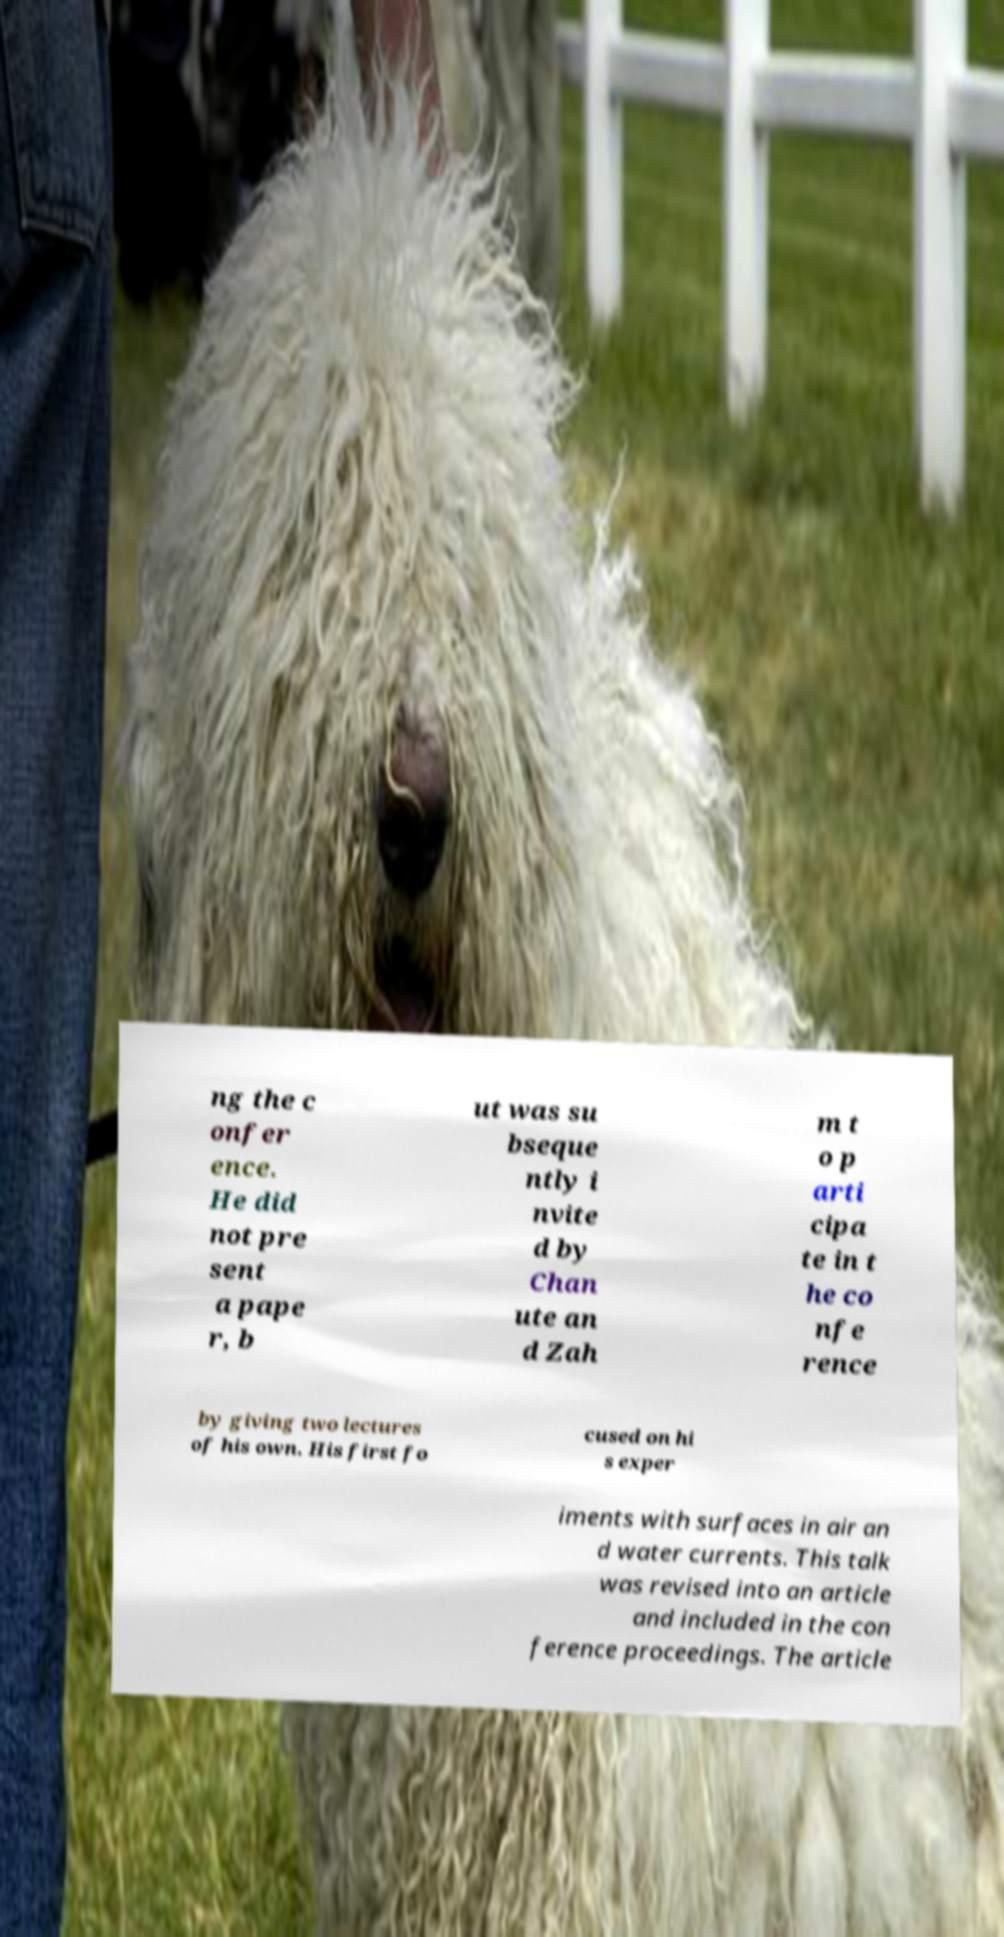Please identify and transcribe the text found in this image. ng the c onfer ence. He did not pre sent a pape r, b ut was su bseque ntly i nvite d by Chan ute an d Zah m t o p arti cipa te in t he co nfe rence by giving two lectures of his own. His first fo cused on hi s exper iments with surfaces in air an d water currents. This talk was revised into an article and included in the con ference proceedings. The article 